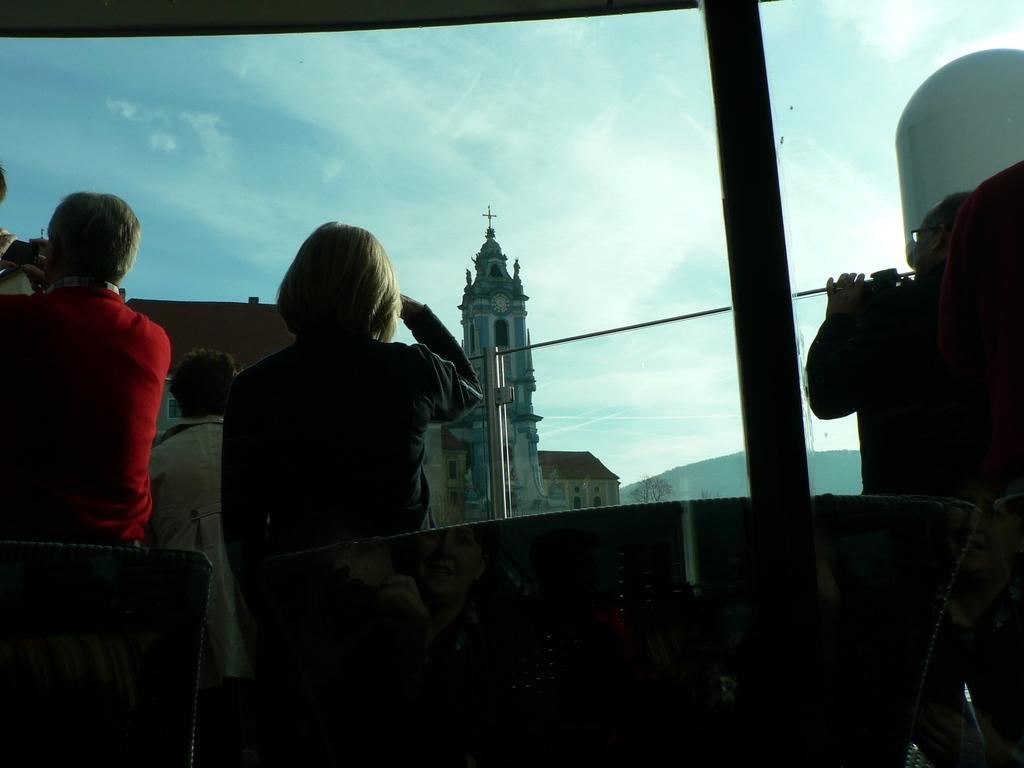What can be seen in the image involving people? There are people standing in the image. What type of structures are visible in the image? There are buildings visible in the image. What is the man in the image holding? The man is holding a camera in his hand. How would you describe the sky in the image? The sky is blue and cloudy. What natural element can be seen through a glass or window? There is a tree visible through a glass or window. What type of pie is being served at the organization's meeting in the image? There is no pie or organization present in the image; it features people standing near buildings with a man holding a camera, a blue and cloudy sky, and a tree visible through a glass or window. 